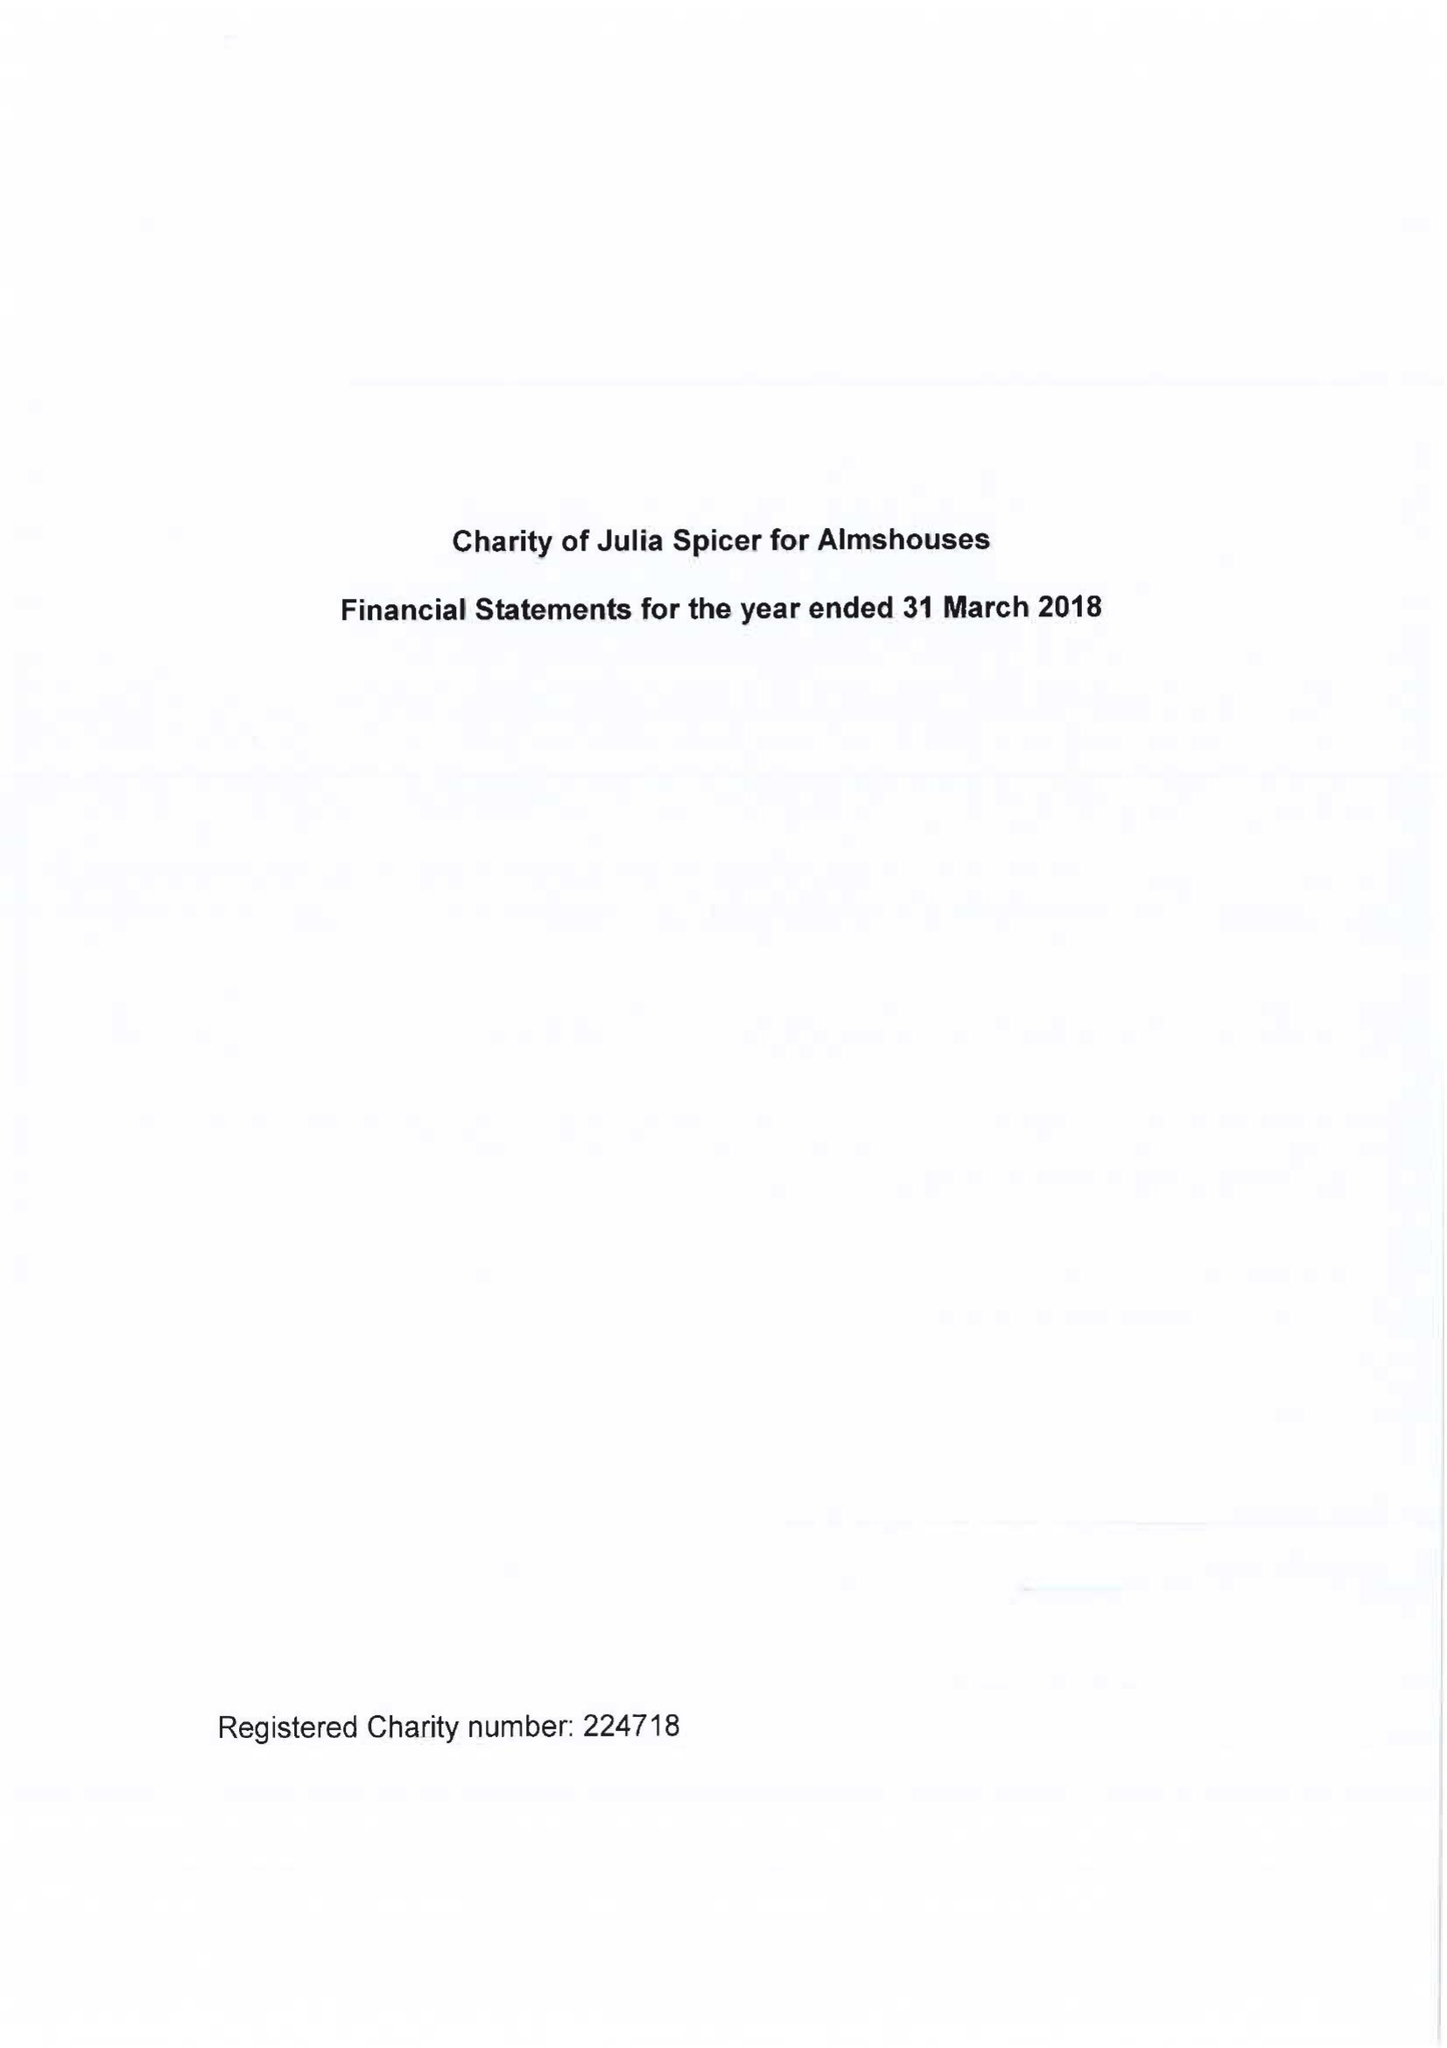What is the value for the address__postcode?
Answer the question using a single word or phrase. CR0 9XP 